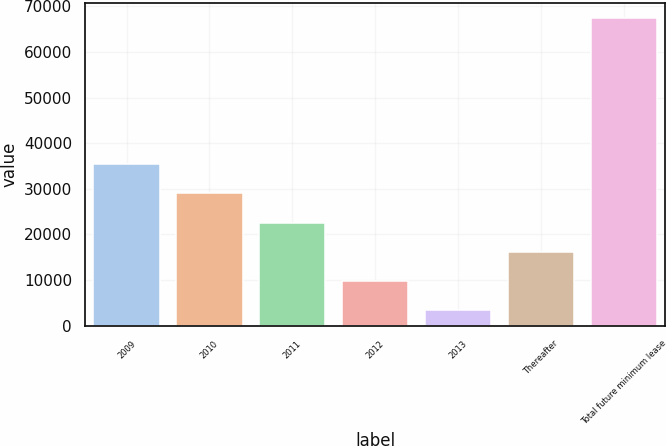Convert chart. <chart><loc_0><loc_0><loc_500><loc_500><bar_chart><fcel>2009<fcel>2010<fcel>2011<fcel>2012<fcel>2013<fcel>Thereafter<fcel>Total future minimum lease<nl><fcel>35405.5<fcel>28997.4<fcel>22589.3<fcel>9773.1<fcel>3365<fcel>16181.2<fcel>67446<nl></chart> 